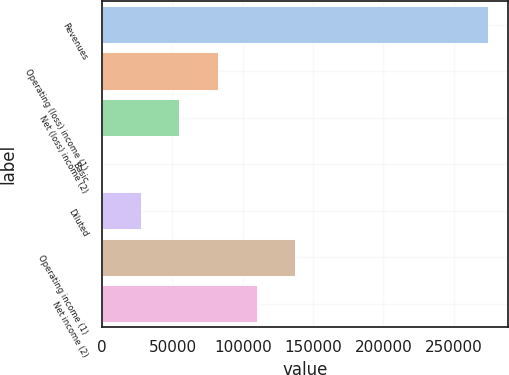<chart> <loc_0><loc_0><loc_500><loc_500><bar_chart><fcel>Revenues<fcel>Operating (loss) income (1)<fcel>Net (loss) income (2)<fcel>Basic<fcel>Diluted<fcel>Operating income (1)<fcel>Net income (2)<nl><fcel>274569<fcel>82370.7<fcel>54913.8<fcel>0.01<fcel>27456.9<fcel>137285<fcel>109828<nl></chart> 